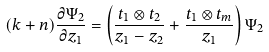Convert formula to latex. <formula><loc_0><loc_0><loc_500><loc_500>( k + n ) \frac { \partial \Psi _ { 2 } } { \partial z _ { 1 } } = \left ( \frac { t _ { 1 } \otimes t _ { 2 } } { z _ { 1 } - z _ { 2 } } + \frac { t _ { 1 } \otimes t _ { m } } { z _ { 1 } } \right ) \Psi _ { 2 }</formula> 